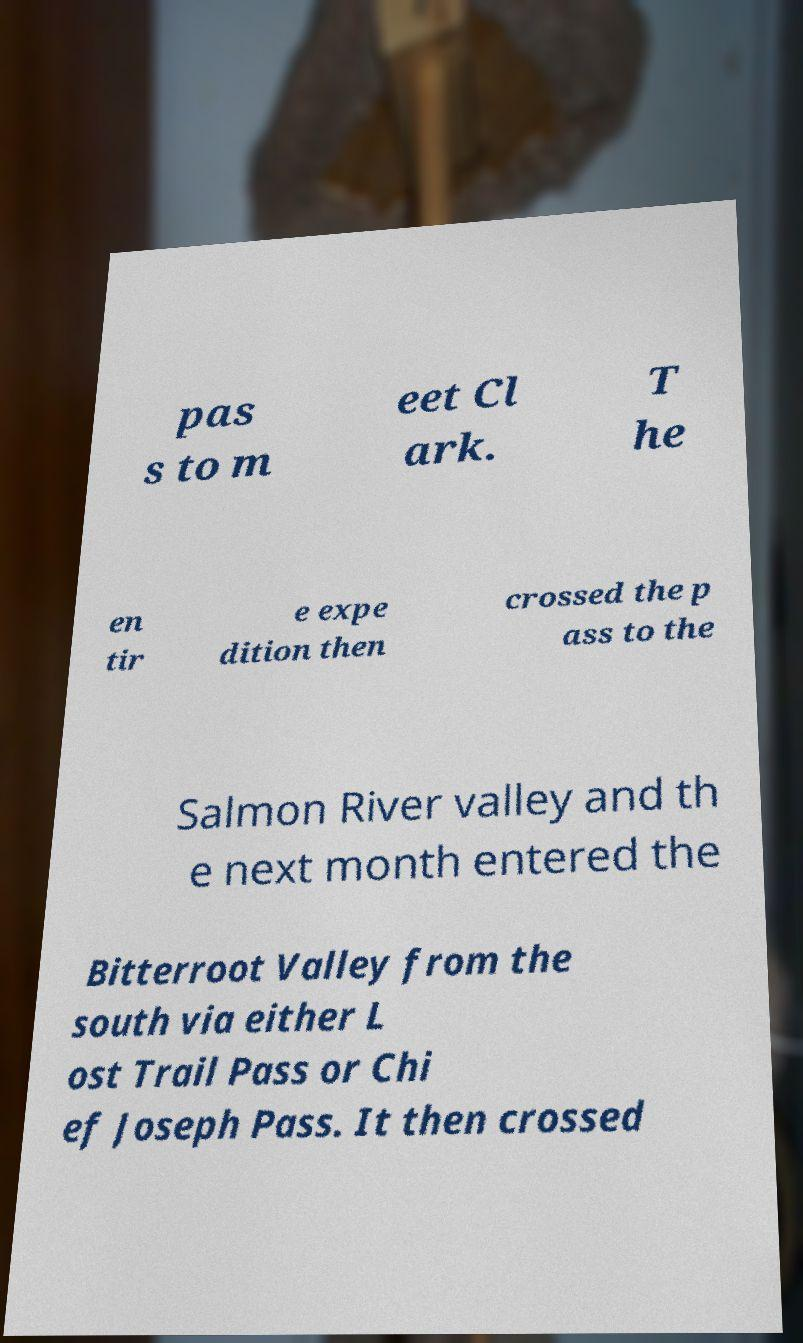Please identify and transcribe the text found in this image. pas s to m eet Cl ark. T he en tir e expe dition then crossed the p ass to the Salmon River valley and th e next month entered the Bitterroot Valley from the south via either L ost Trail Pass or Chi ef Joseph Pass. It then crossed 